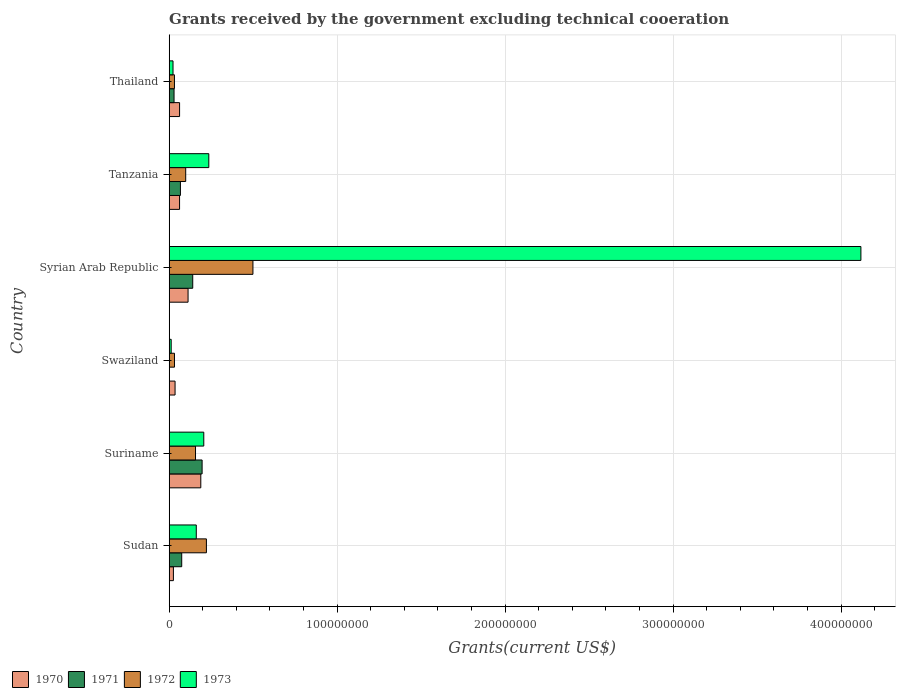How many bars are there on the 3rd tick from the top?
Keep it short and to the point. 4. What is the label of the 4th group of bars from the top?
Offer a terse response. Swaziland. What is the total grants received by the government in 1972 in Suriname?
Provide a short and direct response. 1.57e+07. Across all countries, what is the maximum total grants received by the government in 1971?
Your answer should be compact. 1.96e+07. In which country was the total grants received by the government in 1970 maximum?
Your response must be concise. Suriname. What is the total total grants received by the government in 1970 in the graph?
Provide a succinct answer. 4.84e+07. What is the difference between the total grants received by the government in 1973 in Sudan and that in Thailand?
Provide a succinct answer. 1.38e+07. What is the difference between the total grants received by the government in 1970 in Suriname and the total grants received by the government in 1971 in Thailand?
Make the answer very short. 1.59e+07. What is the average total grants received by the government in 1973 per country?
Provide a succinct answer. 7.93e+07. What is the difference between the total grants received by the government in 1971 and total grants received by the government in 1973 in Sudan?
Offer a terse response. -8.67e+06. What is the ratio of the total grants received by the government in 1973 in Syrian Arab Republic to that in Thailand?
Make the answer very short. 181.41. Is the total grants received by the government in 1971 in Suriname less than that in Thailand?
Offer a terse response. No. Is the difference between the total grants received by the government in 1971 in Syrian Arab Republic and Tanzania greater than the difference between the total grants received by the government in 1973 in Syrian Arab Republic and Tanzania?
Give a very brief answer. No. What is the difference between the highest and the second highest total grants received by the government in 1970?
Your answer should be compact. 7.58e+06. What is the difference between the highest and the lowest total grants received by the government in 1972?
Offer a terse response. 4.67e+07. In how many countries, is the total grants received by the government in 1973 greater than the average total grants received by the government in 1973 taken over all countries?
Your response must be concise. 1. Is the sum of the total grants received by the government in 1971 in Tanzania and Thailand greater than the maximum total grants received by the government in 1972 across all countries?
Ensure brevity in your answer.  No. Is it the case that in every country, the sum of the total grants received by the government in 1971 and total grants received by the government in 1973 is greater than the sum of total grants received by the government in 1972 and total grants received by the government in 1970?
Provide a short and direct response. No. Does the graph contain any zero values?
Your answer should be compact. Yes. Does the graph contain grids?
Give a very brief answer. Yes. Where does the legend appear in the graph?
Provide a succinct answer. Bottom left. What is the title of the graph?
Keep it short and to the point. Grants received by the government excluding technical cooeration. Does "1976" appear as one of the legend labels in the graph?
Offer a terse response. No. What is the label or title of the X-axis?
Provide a succinct answer. Grants(current US$). What is the Grants(current US$) in 1970 in Sudan?
Provide a succinct answer. 2.50e+06. What is the Grants(current US$) of 1971 in Sudan?
Offer a terse response. 7.45e+06. What is the Grants(current US$) in 1972 in Sudan?
Keep it short and to the point. 2.22e+07. What is the Grants(current US$) of 1973 in Sudan?
Offer a very short reply. 1.61e+07. What is the Grants(current US$) of 1970 in Suriname?
Your response must be concise. 1.88e+07. What is the Grants(current US$) of 1971 in Suriname?
Ensure brevity in your answer.  1.96e+07. What is the Grants(current US$) in 1972 in Suriname?
Your response must be concise. 1.57e+07. What is the Grants(current US$) in 1973 in Suriname?
Ensure brevity in your answer.  2.06e+07. What is the Grants(current US$) in 1970 in Swaziland?
Your response must be concise. 3.49e+06. What is the Grants(current US$) of 1972 in Swaziland?
Offer a very short reply. 3.14e+06. What is the Grants(current US$) in 1973 in Swaziland?
Provide a succinct answer. 1.18e+06. What is the Grants(current US$) of 1970 in Syrian Arab Republic?
Ensure brevity in your answer.  1.12e+07. What is the Grants(current US$) of 1971 in Syrian Arab Republic?
Ensure brevity in your answer.  1.40e+07. What is the Grants(current US$) in 1972 in Syrian Arab Republic?
Your answer should be compact. 4.98e+07. What is the Grants(current US$) of 1973 in Syrian Arab Republic?
Your response must be concise. 4.12e+08. What is the Grants(current US$) in 1970 in Tanzania?
Keep it short and to the point. 6.17e+06. What is the Grants(current US$) of 1971 in Tanzania?
Offer a terse response. 6.68e+06. What is the Grants(current US$) of 1972 in Tanzania?
Provide a short and direct response. 9.82e+06. What is the Grants(current US$) in 1973 in Tanzania?
Make the answer very short. 2.36e+07. What is the Grants(current US$) in 1970 in Thailand?
Offer a terse response. 6.18e+06. What is the Grants(current US$) in 1971 in Thailand?
Give a very brief answer. 2.88e+06. What is the Grants(current US$) of 1972 in Thailand?
Your answer should be very brief. 3.12e+06. What is the Grants(current US$) in 1973 in Thailand?
Offer a very short reply. 2.27e+06. Across all countries, what is the maximum Grants(current US$) of 1970?
Offer a very short reply. 1.88e+07. Across all countries, what is the maximum Grants(current US$) in 1971?
Make the answer very short. 1.96e+07. Across all countries, what is the maximum Grants(current US$) in 1972?
Provide a succinct answer. 4.98e+07. Across all countries, what is the maximum Grants(current US$) of 1973?
Make the answer very short. 4.12e+08. Across all countries, what is the minimum Grants(current US$) of 1970?
Your response must be concise. 2.50e+06. Across all countries, what is the minimum Grants(current US$) of 1971?
Give a very brief answer. 0. Across all countries, what is the minimum Grants(current US$) of 1972?
Keep it short and to the point. 3.12e+06. Across all countries, what is the minimum Grants(current US$) of 1973?
Provide a short and direct response. 1.18e+06. What is the total Grants(current US$) in 1970 in the graph?
Offer a very short reply. 4.84e+07. What is the total Grants(current US$) in 1971 in the graph?
Provide a short and direct response. 5.06e+07. What is the total Grants(current US$) of 1972 in the graph?
Provide a short and direct response. 1.04e+08. What is the total Grants(current US$) of 1973 in the graph?
Ensure brevity in your answer.  4.76e+08. What is the difference between the Grants(current US$) of 1970 in Sudan and that in Suriname?
Offer a terse response. -1.63e+07. What is the difference between the Grants(current US$) in 1971 in Sudan and that in Suriname?
Offer a very short reply. -1.21e+07. What is the difference between the Grants(current US$) of 1972 in Sudan and that in Suriname?
Provide a succinct answer. 6.49e+06. What is the difference between the Grants(current US$) of 1973 in Sudan and that in Suriname?
Offer a very short reply. -4.46e+06. What is the difference between the Grants(current US$) of 1970 in Sudan and that in Swaziland?
Give a very brief answer. -9.90e+05. What is the difference between the Grants(current US$) in 1972 in Sudan and that in Swaziland?
Make the answer very short. 1.90e+07. What is the difference between the Grants(current US$) in 1973 in Sudan and that in Swaziland?
Keep it short and to the point. 1.49e+07. What is the difference between the Grants(current US$) in 1970 in Sudan and that in Syrian Arab Republic?
Offer a very short reply. -8.73e+06. What is the difference between the Grants(current US$) of 1971 in Sudan and that in Syrian Arab Republic?
Offer a terse response. -6.56e+06. What is the difference between the Grants(current US$) of 1972 in Sudan and that in Syrian Arab Republic?
Offer a terse response. -2.77e+07. What is the difference between the Grants(current US$) in 1973 in Sudan and that in Syrian Arab Republic?
Keep it short and to the point. -3.96e+08. What is the difference between the Grants(current US$) of 1970 in Sudan and that in Tanzania?
Your response must be concise. -3.67e+06. What is the difference between the Grants(current US$) of 1971 in Sudan and that in Tanzania?
Offer a very short reply. 7.70e+05. What is the difference between the Grants(current US$) of 1972 in Sudan and that in Tanzania?
Make the answer very short. 1.23e+07. What is the difference between the Grants(current US$) in 1973 in Sudan and that in Tanzania?
Give a very brief answer. -7.46e+06. What is the difference between the Grants(current US$) in 1970 in Sudan and that in Thailand?
Make the answer very short. -3.68e+06. What is the difference between the Grants(current US$) in 1971 in Sudan and that in Thailand?
Your answer should be very brief. 4.57e+06. What is the difference between the Grants(current US$) of 1972 in Sudan and that in Thailand?
Give a very brief answer. 1.90e+07. What is the difference between the Grants(current US$) in 1973 in Sudan and that in Thailand?
Your answer should be compact. 1.38e+07. What is the difference between the Grants(current US$) of 1970 in Suriname and that in Swaziland?
Offer a very short reply. 1.53e+07. What is the difference between the Grants(current US$) in 1972 in Suriname and that in Swaziland?
Your answer should be very brief. 1.25e+07. What is the difference between the Grants(current US$) in 1973 in Suriname and that in Swaziland?
Offer a very short reply. 1.94e+07. What is the difference between the Grants(current US$) of 1970 in Suriname and that in Syrian Arab Republic?
Offer a very short reply. 7.58e+06. What is the difference between the Grants(current US$) in 1971 in Suriname and that in Syrian Arab Republic?
Give a very brief answer. 5.58e+06. What is the difference between the Grants(current US$) in 1972 in Suriname and that in Syrian Arab Republic?
Ensure brevity in your answer.  -3.42e+07. What is the difference between the Grants(current US$) in 1973 in Suriname and that in Syrian Arab Republic?
Make the answer very short. -3.91e+08. What is the difference between the Grants(current US$) of 1970 in Suriname and that in Tanzania?
Offer a terse response. 1.26e+07. What is the difference between the Grants(current US$) of 1971 in Suriname and that in Tanzania?
Offer a very short reply. 1.29e+07. What is the difference between the Grants(current US$) of 1972 in Suriname and that in Tanzania?
Your answer should be very brief. 5.84e+06. What is the difference between the Grants(current US$) of 1973 in Suriname and that in Tanzania?
Ensure brevity in your answer.  -3.00e+06. What is the difference between the Grants(current US$) of 1970 in Suriname and that in Thailand?
Your answer should be very brief. 1.26e+07. What is the difference between the Grants(current US$) of 1971 in Suriname and that in Thailand?
Make the answer very short. 1.67e+07. What is the difference between the Grants(current US$) in 1972 in Suriname and that in Thailand?
Offer a terse response. 1.25e+07. What is the difference between the Grants(current US$) of 1973 in Suriname and that in Thailand?
Ensure brevity in your answer.  1.83e+07. What is the difference between the Grants(current US$) in 1970 in Swaziland and that in Syrian Arab Republic?
Your answer should be compact. -7.74e+06. What is the difference between the Grants(current US$) of 1972 in Swaziland and that in Syrian Arab Republic?
Offer a very short reply. -4.67e+07. What is the difference between the Grants(current US$) in 1973 in Swaziland and that in Syrian Arab Republic?
Provide a succinct answer. -4.11e+08. What is the difference between the Grants(current US$) of 1970 in Swaziland and that in Tanzania?
Keep it short and to the point. -2.68e+06. What is the difference between the Grants(current US$) of 1972 in Swaziland and that in Tanzania?
Keep it short and to the point. -6.68e+06. What is the difference between the Grants(current US$) of 1973 in Swaziland and that in Tanzania?
Your response must be concise. -2.24e+07. What is the difference between the Grants(current US$) in 1970 in Swaziland and that in Thailand?
Offer a terse response. -2.69e+06. What is the difference between the Grants(current US$) in 1972 in Swaziland and that in Thailand?
Offer a terse response. 2.00e+04. What is the difference between the Grants(current US$) of 1973 in Swaziland and that in Thailand?
Give a very brief answer. -1.09e+06. What is the difference between the Grants(current US$) of 1970 in Syrian Arab Republic and that in Tanzania?
Offer a very short reply. 5.06e+06. What is the difference between the Grants(current US$) in 1971 in Syrian Arab Republic and that in Tanzania?
Offer a terse response. 7.33e+06. What is the difference between the Grants(current US$) of 1972 in Syrian Arab Republic and that in Tanzania?
Ensure brevity in your answer.  4.00e+07. What is the difference between the Grants(current US$) in 1973 in Syrian Arab Republic and that in Tanzania?
Give a very brief answer. 3.88e+08. What is the difference between the Grants(current US$) of 1970 in Syrian Arab Republic and that in Thailand?
Ensure brevity in your answer.  5.05e+06. What is the difference between the Grants(current US$) in 1971 in Syrian Arab Republic and that in Thailand?
Ensure brevity in your answer.  1.11e+07. What is the difference between the Grants(current US$) of 1972 in Syrian Arab Republic and that in Thailand?
Your response must be concise. 4.67e+07. What is the difference between the Grants(current US$) of 1973 in Syrian Arab Republic and that in Thailand?
Ensure brevity in your answer.  4.10e+08. What is the difference between the Grants(current US$) of 1970 in Tanzania and that in Thailand?
Give a very brief answer. -10000. What is the difference between the Grants(current US$) in 1971 in Tanzania and that in Thailand?
Provide a succinct answer. 3.80e+06. What is the difference between the Grants(current US$) of 1972 in Tanzania and that in Thailand?
Your answer should be very brief. 6.70e+06. What is the difference between the Grants(current US$) of 1973 in Tanzania and that in Thailand?
Make the answer very short. 2.13e+07. What is the difference between the Grants(current US$) of 1970 in Sudan and the Grants(current US$) of 1971 in Suriname?
Give a very brief answer. -1.71e+07. What is the difference between the Grants(current US$) of 1970 in Sudan and the Grants(current US$) of 1972 in Suriname?
Offer a terse response. -1.32e+07. What is the difference between the Grants(current US$) of 1970 in Sudan and the Grants(current US$) of 1973 in Suriname?
Offer a terse response. -1.81e+07. What is the difference between the Grants(current US$) in 1971 in Sudan and the Grants(current US$) in 1972 in Suriname?
Provide a short and direct response. -8.21e+06. What is the difference between the Grants(current US$) of 1971 in Sudan and the Grants(current US$) of 1973 in Suriname?
Provide a short and direct response. -1.31e+07. What is the difference between the Grants(current US$) in 1972 in Sudan and the Grants(current US$) in 1973 in Suriname?
Provide a short and direct response. 1.57e+06. What is the difference between the Grants(current US$) of 1970 in Sudan and the Grants(current US$) of 1972 in Swaziland?
Your answer should be compact. -6.40e+05. What is the difference between the Grants(current US$) of 1970 in Sudan and the Grants(current US$) of 1973 in Swaziland?
Your response must be concise. 1.32e+06. What is the difference between the Grants(current US$) of 1971 in Sudan and the Grants(current US$) of 1972 in Swaziland?
Give a very brief answer. 4.31e+06. What is the difference between the Grants(current US$) of 1971 in Sudan and the Grants(current US$) of 1973 in Swaziland?
Offer a very short reply. 6.27e+06. What is the difference between the Grants(current US$) of 1972 in Sudan and the Grants(current US$) of 1973 in Swaziland?
Your response must be concise. 2.10e+07. What is the difference between the Grants(current US$) in 1970 in Sudan and the Grants(current US$) in 1971 in Syrian Arab Republic?
Your answer should be compact. -1.15e+07. What is the difference between the Grants(current US$) of 1970 in Sudan and the Grants(current US$) of 1972 in Syrian Arab Republic?
Give a very brief answer. -4.74e+07. What is the difference between the Grants(current US$) of 1970 in Sudan and the Grants(current US$) of 1973 in Syrian Arab Republic?
Provide a short and direct response. -4.09e+08. What is the difference between the Grants(current US$) in 1971 in Sudan and the Grants(current US$) in 1972 in Syrian Arab Republic?
Ensure brevity in your answer.  -4.24e+07. What is the difference between the Grants(current US$) of 1971 in Sudan and the Grants(current US$) of 1973 in Syrian Arab Republic?
Keep it short and to the point. -4.04e+08. What is the difference between the Grants(current US$) in 1972 in Sudan and the Grants(current US$) in 1973 in Syrian Arab Republic?
Ensure brevity in your answer.  -3.90e+08. What is the difference between the Grants(current US$) in 1970 in Sudan and the Grants(current US$) in 1971 in Tanzania?
Offer a very short reply. -4.18e+06. What is the difference between the Grants(current US$) in 1970 in Sudan and the Grants(current US$) in 1972 in Tanzania?
Ensure brevity in your answer.  -7.32e+06. What is the difference between the Grants(current US$) of 1970 in Sudan and the Grants(current US$) of 1973 in Tanzania?
Your response must be concise. -2.11e+07. What is the difference between the Grants(current US$) of 1971 in Sudan and the Grants(current US$) of 1972 in Tanzania?
Make the answer very short. -2.37e+06. What is the difference between the Grants(current US$) of 1971 in Sudan and the Grants(current US$) of 1973 in Tanzania?
Ensure brevity in your answer.  -1.61e+07. What is the difference between the Grants(current US$) of 1972 in Sudan and the Grants(current US$) of 1973 in Tanzania?
Your answer should be compact. -1.43e+06. What is the difference between the Grants(current US$) of 1970 in Sudan and the Grants(current US$) of 1971 in Thailand?
Provide a short and direct response. -3.80e+05. What is the difference between the Grants(current US$) in 1970 in Sudan and the Grants(current US$) in 1972 in Thailand?
Keep it short and to the point. -6.20e+05. What is the difference between the Grants(current US$) in 1971 in Sudan and the Grants(current US$) in 1972 in Thailand?
Offer a very short reply. 4.33e+06. What is the difference between the Grants(current US$) in 1971 in Sudan and the Grants(current US$) in 1973 in Thailand?
Your answer should be very brief. 5.18e+06. What is the difference between the Grants(current US$) of 1972 in Sudan and the Grants(current US$) of 1973 in Thailand?
Make the answer very short. 1.99e+07. What is the difference between the Grants(current US$) in 1970 in Suriname and the Grants(current US$) in 1972 in Swaziland?
Give a very brief answer. 1.57e+07. What is the difference between the Grants(current US$) in 1970 in Suriname and the Grants(current US$) in 1973 in Swaziland?
Your answer should be very brief. 1.76e+07. What is the difference between the Grants(current US$) of 1971 in Suriname and the Grants(current US$) of 1972 in Swaziland?
Keep it short and to the point. 1.64e+07. What is the difference between the Grants(current US$) in 1971 in Suriname and the Grants(current US$) in 1973 in Swaziland?
Ensure brevity in your answer.  1.84e+07. What is the difference between the Grants(current US$) of 1972 in Suriname and the Grants(current US$) of 1973 in Swaziland?
Your response must be concise. 1.45e+07. What is the difference between the Grants(current US$) of 1970 in Suriname and the Grants(current US$) of 1971 in Syrian Arab Republic?
Keep it short and to the point. 4.80e+06. What is the difference between the Grants(current US$) of 1970 in Suriname and the Grants(current US$) of 1972 in Syrian Arab Republic?
Ensure brevity in your answer.  -3.10e+07. What is the difference between the Grants(current US$) of 1970 in Suriname and the Grants(current US$) of 1973 in Syrian Arab Republic?
Your answer should be compact. -3.93e+08. What is the difference between the Grants(current US$) in 1971 in Suriname and the Grants(current US$) in 1972 in Syrian Arab Republic?
Your answer should be very brief. -3.03e+07. What is the difference between the Grants(current US$) in 1971 in Suriname and the Grants(current US$) in 1973 in Syrian Arab Republic?
Your answer should be very brief. -3.92e+08. What is the difference between the Grants(current US$) in 1972 in Suriname and the Grants(current US$) in 1973 in Syrian Arab Republic?
Offer a very short reply. -3.96e+08. What is the difference between the Grants(current US$) of 1970 in Suriname and the Grants(current US$) of 1971 in Tanzania?
Give a very brief answer. 1.21e+07. What is the difference between the Grants(current US$) in 1970 in Suriname and the Grants(current US$) in 1972 in Tanzania?
Your answer should be compact. 8.99e+06. What is the difference between the Grants(current US$) of 1970 in Suriname and the Grants(current US$) of 1973 in Tanzania?
Make the answer very short. -4.77e+06. What is the difference between the Grants(current US$) of 1971 in Suriname and the Grants(current US$) of 1972 in Tanzania?
Provide a short and direct response. 9.77e+06. What is the difference between the Grants(current US$) in 1971 in Suriname and the Grants(current US$) in 1973 in Tanzania?
Offer a terse response. -3.99e+06. What is the difference between the Grants(current US$) of 1972 in Suriname and the Grants(current US$) of 1973 in Tanzania?
Your answer should be compact. -7.92e+06. What is the difference between the Grants(current US$) of 1970 in Suriname and the Grants(current US$) of 1971 in Thailand?
Offer a very short reply. 1.59e+07. What is the difference between the Grants(current US$) in 1970 in Suriname and the Grants(current US$) in 1972 in Thailand?
Offer a terse response. 1.57e+07. What is the difference between the Grants(current US$) of 1970 in Suriname and the Grants(current US$) of 1973 in Thailand?
Ensure brevity in your answer.  1.65e+07. What is the difference between the Grants(current US$) of 1971 in Suriname and the Grants(current US$) of 1972 in Thailand?
Give a very brief answer. 1.65e+07. What is the difference between the Grants(current US$) of 1971 in Suriname and the Grants(current US$) of 1973 in Thailand?
Your answer should be compact. 1.73e+07. What is the difference between the Grants(current US$) in 1972 in Suriname and the Grants(current US$) in 1973 in Thailand?
Ensure brevity in your answer.  1.34e+07. What is the difference between the Grants(current US$) in 1970 in Swaziland and the Grants(current US$) in 1971 in Syrian Arab Republic?
Provide a succinct answer. -1.05e+07. What is the difference between the Grants(current US$) in 1970 in Swaziland and the Grants(current US$) in 1972 in Syrian Arab Republic?
Make the answer very short. -4.64e+07. What is the difference between the Grants(current US$) of 1970 in Swaziland and the Grants(current US$) of 1973 in Syrian Arab Republic?
Your answer should be compact. -4.08e+08. What is the difference between the Grants(current US$) of 1972 in Swaziland and the Grants(current US$) of 1973 in Syrian Arab Republic?
Your answer should be compact. -4.09e+08. What is the difference between the Grants(current US$) of 1970 in Swaziland and the Grants(current US$) of 1971 in Tanzania?
Offer a very short reply. -3.19e+06. What is the difference between the Grants(current US$) of 1970 in Swaziland and the Grants(current US$) of 1972 in Tanzania?
Your answer should be very brief. -6.33e+06. What is the difference between the Grants(current US$) of 1970 in Swaziland and the Grants(current US$) of 1973 in Tanzania?
Your answer should be compact. -2.01e+07. What is the difference between the Grants(current US$) of 1972 in Swaziland and the Grants(current US$) of 1973 in Tanzania?
Your response must be concise. -2.04e+07. What is the difference between the Grants(current US$) of 1970 in Swaziland and the Grants(current US$) of 1971 in Thailand?
Provide a short and direct response. 6.10e+05. What is the difference between the Grants(current US$) of 1970 in Swaziland and the Grants(current US$) of 1972 in Thailand?
Your answer should be very brief. 3.70e+05. What is the difference between the Grants(current US$) of 1970 in Swaziland and the Grants(current US$) of 1973 in Thailand?
Ensure brevity in your answer.  1.22e+06. What is the difference between the Grants(current US$) in 1972 in Swaziland and the Grants(current US$) in 1973 in Thailand?
Your response must be concise. 8.70e+05. What is the difference between the Grants(current US$) in 1970 in Syrian Arab Republic and the Grants(current US$) in 1971 in Tanzania?
Your answer should be very brief. 4.55e+06. What is the difference between the Grants(current US$) of 1970 in Syrian Arab Republic and the Grants(current US$) of 1972 in Tanzania?
Keep it short and to the point. 1.41e+06. What is the difference between the Grants(current US$) of 1970 in Syrian Arab Republic and the Grants(current US$) of 1973 in Tanzania?
Offer a very short reply. -1.24e+07. What is the difference between the Grants(current US$) of 1971 in Syrian Arab Republic and the Grants(current US$) of 1972 in Tanzania?
Provide a succinct answer. 4.19e+06. What is the difference between the Grants(current US$) of 1971 in Syrian Arab Republic and the Grants(current US$) of 1973 in Tanzania?
Ensure brevity in your answer.  -9.57e+06. What is the difference between the Grants(current US$) of 1972 in Syrian Arab Republic and the Grants(current US$) of 1973 in Tanzania?
Ensure brevity in your answer.  2.63e+07. What is the difference between the Grants(current US$) in 1970 in Syrian Arab Republic and the Grants(current US$) in 1971 in Thailand?
Offer a very short reply. 8.35e+06. What is the difference between the Grants(current US$) of 1970 in Syrian Arab Republic and the Grants(current US$) of 1972 in Thailand?
Your response must be concise. 8.11e+06. What is the difference between the Grants(current US$) of 1970 in Syrian Arab Republic and the Grants(current US$) of 1973 in Thailand?
Ensure brevity in your answer.  8.96e+06. What is the difference between the Grants(current US$) in 1971 in Syrian Arab Republic and the Grants(current US$) in 1972 in Thailand?
Provide a succinct answer. 1.09e+07. What is the difference between the Grants(current US$) in 1971 in Syrian Arab Republic and the Grants(current US$) in 1973 in Thailand?
Offer a very short reply. 1.17e+07. What is the difference between the Grants(current US$) in 1972 in Syrian Arab Republic and the Grants(current US$) in 1973 in Thailand?
Your answer should be very brief. 4.76e+07. What is the difference between the Grants(current US$) in 1970 in Tanzania and the Grants(current US$) in 1971 in Thailand?
Your answer should be compact. 3.29e+06. What is the difference between the Grants(current US$) in 1970 in Tanzania and the Grants(current US$) in 1972 in Thailand?
Your response must be concise. 3.05e+06. What is the difference between the Grants(current US$) of 1970 in Tanzania and the Grants(current US$) of 1973 in Thailand?
Give a very brief answer. 3.90e+06. What is the difference between the Grants(current US$) of 1971 in Tanzania and the Grants(current US$) of 1972 in Thailand?
Provide a short and direct response. 3.56e+06. What is the difference between the Grants(current US$) in 1971 in Tanzania and the Grants(current US$) in 1973 in Thailand?
Ensure brevity in your answer.  4.41e+06. What is the difference between the Grants(current US$) of 1972 in Tanzania and the Grants(current US$) of 1973 in Thailand?
Give a very brief answer. 7.55e+06. What is the average Grants(current US$) of 1970 per country?
Your response must be concise. 8.06e+06. What is the average Grants(current US$) of 1971 per country?
Make the answer very short. 8.44e+06. What is the average Grants(current US$) in 1972 per country?
Give a very brief answer. 1.73e+07. What is the average Grants(current US$) of 1973 per country?
Offer a very short reply. 7.93e+07. What is the difference between the Grants(current US$) of 1970 and Grants(current US$) of 1971 in Sudan?
Provide a short and direct response. -4.95e+06. What is the difference between the Grants(current US$) of 1970 and Grants(current US$) of 1972 in Sudan?
Your response must be concise. -1.96e+07. What is the difference between the Grants(current US$) in 1970 and Grants(current US$) in 1973 in Sudan?
Your answer should be compact. -1.36e+07. What is the difference between the Grants(current US$) of 1971 and Grants(current US$) of 1972 in Sudan?
Give a very brief answer. -1.47e+07. What is the difference between the Grants(current US$) in 1971 and Grants(current US$) in 1973 in Sudan?
Your answer should be very brief. -8.67e+06. What is the difference between the Grants(current US$) in 1972 and Grants(current US$) in 1973 in Sudan?
Make the answer very short. 6.03e+06. What is the difference between the Grants(current US$) in 1970 and Grants(current US$) in 1971 in Suriname?
Provide a succinct answer. -7.80e+05. What is the difference between the Grants(current US$) of 1970 and Grants(current US$) of 1972 in Suriname?
Offer a terse response. 3.15e+06. What is the difference between the Grants(current US$) in 1970 and Grants(current US$) in 1973 in Suriname?
Ensure brevity in your answer.  -1.77e+06. What is the difference between the Grants(current US$) in 1971 and Grants(current US$) in 1972 in Suriname?
Provide a short and direct response. 3.93e+06. What is the difference between the Grants(current US$) in 1971 and Grants(current US$) in 1973 in Suriname?
Your answer should be compact. -9.90e+05. What is the difference between the Grants(current US$) in 1972 and Grants(current US$) in 1973 in Suriname?
Provide a succinct answer. -4.92e+06. What is the difference between the Grants(current US$) in 1970 and Grants(current US$) in 1973 in Swaziland?
Your answer should be compact. 2.31e+06. What is the difference between the Grants(current US$) in 1972 and Grants(current US$) in 1973 in Swaziland?
Provide a short and direct response. 1.96e+06. What is the difference between the Grants(current US$) of 1970 and Grants(current US$) of 1971 in Syrian Arab Republic?
Your answer should be compact. -2.78e+06. What is the difference between the Grants(current US$) of 1970 and Grants(current US$) of 1972 in Syrian Arab Republic?
Offer a very short reply. -3.86e+07. What is the difference between the Grants(current US$) in 1970 and Grants(current US$) in 1973 in Syrian Arab Republic?
Provide a succinct answer. -4.01e+08. What is the difference between the Grants(current US$) of 1971 and Grants(current US$) of 1972 in Syrian Arab Republic?
Keep it short and to the point. -3.58e+07. What is the difference between the Grants(current US$) in 1971 and Grants(current US$) in 1973 in Syrian Arab Republic?
Provide a short and direct response. -3.98e+08. What is the difference between the Grants(current US$) of 1972 and Grants(current US$) of 1973 in Syrian Arab Republic?
Give a very brief answer. -3.62e+08. What is the difference between the Grants(current US$) in 1970 and Grants(current US$) in 1971 in Tanzania?
Give a very brief answer. -5.10e+05. What is the difference between the Grants(current US$) of 1970 and Grants(current US$) of 1972 in Tanzania?
Keep it short and to the point. -3.65e+06. What is the difference between the Grants(current US$) in 1970 and Grants(current US$) in 1973 in Tanzania?
Offer a very short reply. -1.74e+07. What is the difference between the Grants(current US$) in 1971 and Grants(current US$) in 1972 in Tanzania?
Offer a terse response. -3.14e+06. What is the difference between the Grants(current US$) of 1971 and Grants(current US$) of 1973 in Tanzania?
Make the answer very short. -1.69e+07. What is the difference between the Grants(current US$) in 1972 and Grants(current US$) in 1973 in Tanzania?
Provide a succinct answer. -1.38e+07. What is the difference between the Grants(current US$) of 1970 and Grants(current US$) of 1971 in Thailand?
Offer a very short reply. 3.30e+06. What is the difference between the Grants(current US$) in 1970 and Grants(current US$) in 1972 in Thailand?
Offer a very short reply. 3.06e+06. What is the difference between the Grants(current US$) of 1970 and Grants(current US$) of 1973 in Thailand?
Provide a short and direct response. 3.91e+06. What is the difference between the Grants(current US$) in 1972 and Grants(current US$) in 1973 in Thailand?
Offer a very short reply. 8.50e+05. What is the ratio of the Grants(current US$) of 1970 in Sudan to that in Suriname?
Give a very brief answer. 0.13. What is the ratio of the Grants(current US$) in 1971 in Sudan to that in Suriname?
Your answer should be compact. 0.38. What is the ratio of the Grants(current US$) of 1972 in Sudan to that in Suriname?
Provide a short and direct response. 1.41. What is the ratio of the Grants(current US$) of 1973 in Sudan to that in Suriname?
Keep it short and to the point. 0.78. What is the ratio of the Grants(current US$) in 1970 in Sudan to that in Swaziland?
Offer a terse response. 0.72. What is the ratio of the Grants(current US$) of 1972 in Sudan to that in Swaziland?
Ensure brevity in your answer.  7.05. What is the ratio of the Grants(current US$) in 1973 in Sudan to that in Swaziland?
Your response must be concise. 13.66. What is the ratio of the Grants(current US$) in 1970 in Sudan to that in Syrian Arab Republic?
Offer a terse response. 0.22. What is the ratio of the Grants(current US$) in 1971 in Sudan to that in Syrian Arab Republic?
Your answer should be compact. 0.53. What is the ratio of the Grants(current US$) of 1972 in Sudan to that in Syrian Arab Republic?
Provide a short and direct response. 0.44. What is the ratio of the Grants(current US$) in 1973 in Sudan to that in Syrian Arab Republic?
Offer a terse response. 0.04. What is the ratio of the Grants(current US$) of 1970 in Sudan to that in Tanzania?
Your response must be concise. 0.41. What is the ratio of the Grants(current US$) of 1971 in Sudan to that in Tanzania?
Offer a very short reply. 1.12. What is the ratio of the Grants(current US$) of 1972 in Sudan to that in Tanzania?
Offer a very short reply. 2.26. What is the ratio of the Grants(current US$) of 1973 in Sudan to that in Tanzania?
Your response must be concise. 0.68. What is the ratio of the Grants(current US$) in 1970 in Sudan to that in Thailand?
Your response must be concise. 0.4. What is the ratio of the Grants(current US$) of 1971 in Sudan to that in Thailand?
Make the answer very short. 2.59. What is the ratio of the Grants(current US$) in 1972 in Sudan to that in Thailand?
Make the answer very short. 7.1. What is the ratio of the Grants(current US$) of 1973 in Sudan to that in Thailand?
Ensure brevity in your answer.  7.1. What is the ratio of the Grants(current US$) in 1970 in Suriname to that in Swaziland?
Your response must be concise. 5.39. What is the ratio of the Grants(current US$) in 1972 in Suriname to that in Swaziland?
Provide a short and direct response. 4.99. What is the ratio of the Grants(current US$) in 1973 in Suriname to that in Swaziland?
Your response must be concise. 17.44. What is the ratio of the Grants(current US$) in 1970 in Suriname to that in Syrian Arab Republic?
Your response must be concise. 1.68. What is the ratio of the Grants(current US$) of 1971 in Suriname to that in Syrian Arab Republic?
Offer a terse response. 1.4. What is the ratio of the Grants(current US$) in 1972 in Suriname to that in Syrian Arab Republic?
Offer a very short reply. 0.31. What is the ratio of the Grants(current US$) in 1970 in Suriname to that in Tanzania?
Provide a succinct answer. 3.05. What is the ratio of the Grants(current US$) in 1971 in Suriname to that in Tanzania?
Your answer should be very brief. 2.93. What is the ratio of the Grants(current US$) of 1972 in Suriname to that in Tanzania?
Your answer should be very brief. 1.59. What is the ratio of the Grants(current US$) in 1973 in Suriname to that in Tanzania?
Ensure brevity in your answer.  0.87. What is the ratio of the Grants(current US$) in 1970 in Suriname to that in Thailand?
Your answer should be compact. 3.04. What is the ratio of the Grants(current US$) of 1971 in Suriname to that in Thailand?
Offer a terse response. 6.8. What is the ratio of the Grants(current US$) of 1972 in Suriname to that in Thailand?
Make the answer very short. 5.02. What is the ratio of the Grants(current US$) of 1973 in Suriname to that in Thailand?
Your response must be concise. 9.07. What is the ratio of the Grants(current US$) in 1970 in Swaziland to that in Syrian Arab Republic?
Give a very brief answer. 0.31. What is the ratio of the Grants(current US$) in 1972 in Swaziland to that in Syrian Arab Republic?
Make the answer very short. 0.06. What is the ratio of the Grants(current US$) of 1973 in Swaziland to that in Syrian Arab Republic?
Your answer should be very brief. 0. What is the ratio of the Grants(current US$) of 1970 in Swaziland to that in Tanzania?
Provide a succinct answer. 0.57. What is the ratio of the Grants(current US$) of 1972 in Swaziland to that in Tanzania?
Your answer should be very brief. 0.32. What is the ratio of the Grants(current US$) in 1973 in Swaziland to that in Tanzania?
Offer a very short reply. 0.05. What is the ratio of the Grants(current US$) in 1970 in Swaziland to that in Thailand?
Your answer should be compact. 0.56. What is the ratio of the Grants(current US$) in 1972 in Swaziland to that in Thailand?
Your answer should be very brief. 1.01. What is the ratio of the Grants(current US$) in 1973 in Swaziland to that in Thailand?
Your answer should be very brief. 0.52. What is the ratio of the Grants(current US$) of 1970 in Syrian Arab Republic to that in Tanzania?
Make the answer very short. 1.82. What is the ratio of the Grants(current US$) of 1971 in Syrian Arab Republic to that in Tanzania?
Ensure brevity in your answer.  2.1. What is the ratio of the Grants(current US$) of 1972 in Syrian Arab Republic to that in Tanzania?
Keep it short and to the point. 5.08. What is the ratio of the Grants(current US$) of 1973 in Syrian Arab Republic to that in Tanzania?
Your answer should be compact. 17.46. What is the ratio of the Grants(current US$) in 1970 in Syrian Arab Republic to that in Thailand?
Keep it short and to the point. 1.82. What is the ratio of the Grants(current US$) in 1971 in Syrian Arab Republic to that in Thailand?
Offer a terse response. 4.86. What is the ratio of the Grants(current US$) in 1972 in Syrian Arab Republic to that in Thailand?
Your response must be concise. 15.98. What is the ratio of the Grants(current US$) of 1973 in Syrian Arab Republic to that in Thailand?
Your answer should be compact. 181.41. What is the ratio of the Grants(current US$) in 1971 in Tanzania to that in Thailand?
Offer a terse response. 2.32. What is the ratio of the Grants(current US$) in 1972 in Tanzania to that in Thailand?
Offer a terse response. 3.15. What is the ratio of the Grants(current US$) of 1973 in Tanzania to that in Thailand?
Offer a terse response. 10.39. What is the difference between the highest and the second highest Grants(current US$) in 1970?
Your answer should be very brief. 7.58e+06. What is the difference between the highest and the second highest Grants(current US$) in 1971?
Provide a succinct answer. 5.58e+06. What is the difference between the highest and the second highest Grants(current US$) in 1972?
Give a very brief answer. 2.77e+07. What is the difference between the highest and the second highest Grants(current US$) in 1973?
Offer a very short reply. 3.88e+08. What is the difference between the highest and the lowest Grants(current US$) in 1970?
Keep it short and to the point. 1.63e+07. What is the difference between the highest and the lowest Grants(current US$) in 1971?
Make the answer very short. 1.96e+07. What is the difference between the highest and the lowest Grants(current US$) in 1972?
Give a very brief answer. 4.67e+07. What is the difference between the highest and the lowest Grants(current US$) in 1973?
Your answer should be very brief. 4.11e+08. 